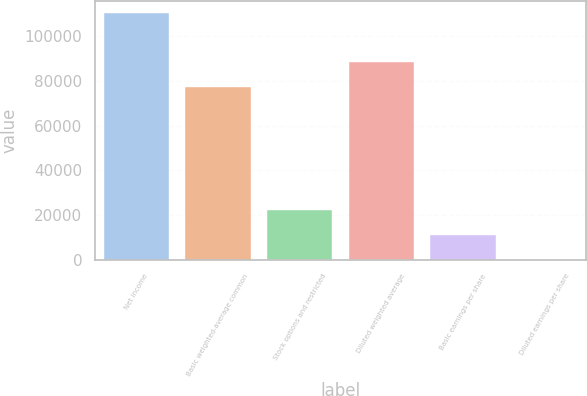<chart> <loc_0><loc_0><loc_500><loc_500><bar_chart><fcel>Net income<fcel>Basic weighted-average common<fcel>Stock options and restricted<fcel>Diluted weighted average<fcel>Basic earnings per share<fcel>Diluted earnings per share<nl><fcel>110303<fcel>77378<fcel>22061.7<fcel>88408.2<fcel>11031.6<fcel>1.4<nl></chart> 